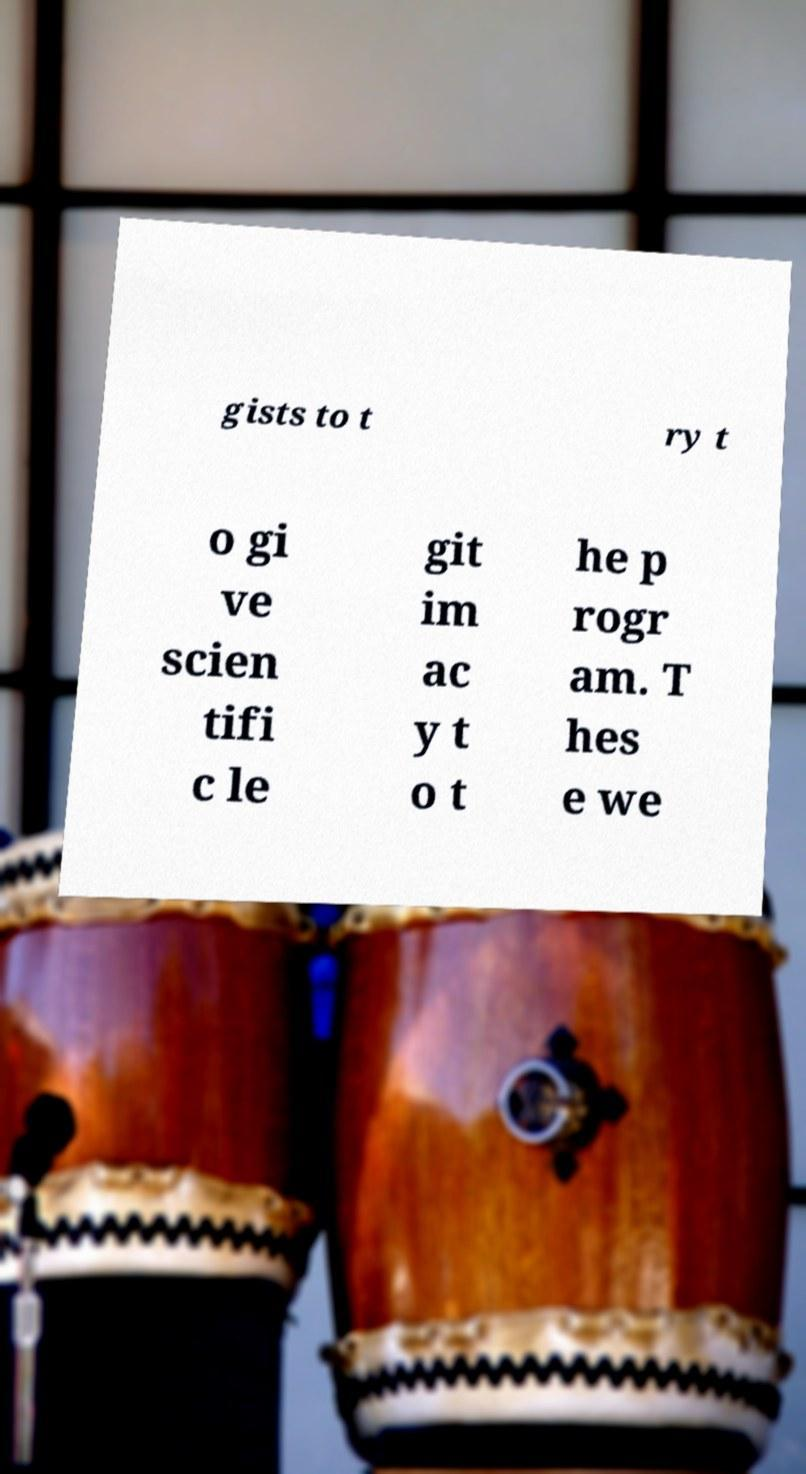There's text embedded in this image that I need extracted. Can you transcribe it verbatim? gists to t ry t o gi ve scien tifi c le git im ac y t o t he p rogr am. T hes e we 